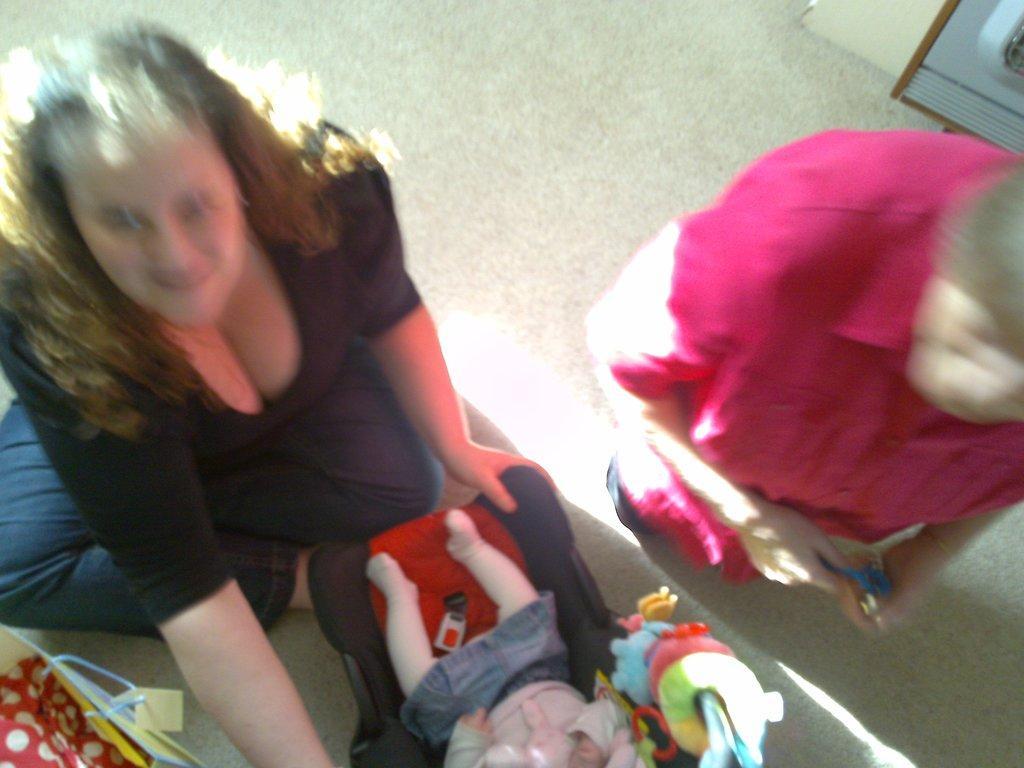Describe this image in one or two sentences. In this image I can see two persons. In front the person is wearing black and blue color dress and I can also see the toy baby and I can also see few toys in multicolor. 